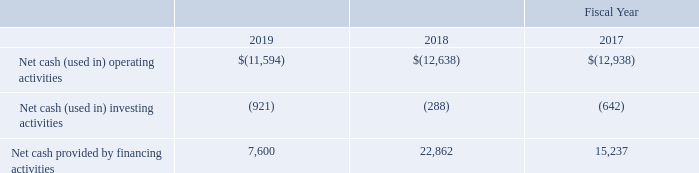Cash balances held at our foreign subsidiaries were approximately $548,000 and $656,000 at December 29, 2019 and December 30, 2018, respectively. Earnings from our foreign subsidiaries are currently deemed to be indefinitely reinvested. We do not expect such reinvestment to affect our liquidity and capital resources, and we continually evaluate our liquidity needs and ability to meet global cash requirements as a part of our overall capital deployment strategy. Factors which affect our liquidity, capital resources and global capital deployment strategy include anticipated cash flows, the ability to repatriate cash in a tax efficient manner, funding requirements for operations and investment activities, acquisitions and divestitures and capital market conditions.
In summary, our cash flows were as follows (in thousands):
Net Cash from Operating Activities
In 2019, net cash used in operating activities was $11.6 million, which was primarily due to a net loss of $15.4 million, adjusted for non-cash charges of $4.3 million. Non-cash charges consisted primarily stock-based compensation expense of $3.1 million and depreciation and amortization of long-lived assets and certain definite- lived intangible assets of $1.2 million. In addition, changes in working capital accounts used cash of $392,000 as a result of a decrease in accounts payable and accrued liabilities of $1.5 million, partially offset by cash inflow from a decrease in inventory of $483,000, a decrease in accounts receivable of $218,000, a decrease in other assets of $229,000 and an increase in deferred revenue of $158,000.
In 2018, net cash used in operating activities was $12.6 million, and resulted primarily from a net loss of $13.8 million, adjusted for non-cash charges of $3.6 million. These non-cash charges included write-downs of inventories in the amount of $386,000 to reflect excess quantities, depreciation and amortization of our long-lived assets of $1.3 million and stock-based compensation of $1.9 million. In addition, changes in working capital accounts used cash of $2.4 million as a result of an increase in accounts receivable of $1.3 million, an increase in gross inventory of $662,000, and an increase in other assets of $879,000, partially offset by an increase in accrued liabilities of $235,000 and an increase in trade payables of $223,000.
In 2017, net cash used in operating activities was $12.9 million, and resulted primarily from a net loss of $14.1 million, adjusted for non-cash charges of $3.1 million. These non-cash charges included write-downs of inventories in the amount of $232,000 to reflect excess quantities, depreciation and amortization of our long-lived assets of $1.4 million and stock-based compensation of $1.4 million. In addition, changes in working capital accounts used cash of $1.9 million as a result of an increase in accounts receivable of $86,000, an increase in gross inventory of $1.8 million, and a decrease of accounts payable of $145,000, partially offset by an increase in accrued liabilities of $72,000.
Net Cash from Investing Activities
Net cash used for investing activities in 2019 was $921,000, which was primarily attributable to the leasehold improvements and computer equipment at the new office premises of $576,000 and capitalization of internal use software of $365,000.
Net cash used for investing activities in 2018 was $288,000, primarily for capital expenditures to acquire manufacturing equipment and software, which was partially offset by proceeds from the sale of old equipment.
Net cash used for investing activities in 2017 was $642,000, primarily for capital expenditures to acquire manufacturing equipment and software.
Net Cash from Financing Activities
In 2019, net cash provided by financing activities was $7.6 million, primarily attributable to the net proceeds from the issuance of 1.3 million shares of common stock in June 2019. These inflows were partially offset by scheduled repayments of finance lease obligations and tax payments related to net settlement of stock awards.
In 2018, net cash provided by financing activities was $22.9 million, resulting from the additional borrowing of $9.0 million under the line of credit, net cash proceeds of $13.9 million from our common stock offering in May 2018 and proceeds of $676,000 from the issuance of common shares to employees under our equity plans. These proceeds were partially offset by scheduled payments of finance lease obligations and tax payments related to net settlement of stock awards.
In 2017, net cash provided by financing activities was $15.2 million, resulting from the proceeds of $15.2 million from our stock offering in March 2017 and proceeds of $352,000 from the issuance of common shares to employees under our equity plans, net of taxes paid related to net settlement of equity awards of $198,000. These proceeds were partially offset by payments of $344,000 under the terms of our capital software lease obligations.
We require substantial cash to fund our business. However, we believe that our existing cash and cash equivalents, together with available financial resources from the Revolving Facility will be sufficient to satisfy our operations and capital expenditures over the next twelve months. OurRevolving Facility will expire in September 2021, and we expect to renew this line of credit or find an alternative lender prior to the expiration date. Further, any violations of debt covenants may restrict our access to any additional cash draws from the revolving line of credit, and may require our immediate repayment of the outstanding debt amounts. After the next twelve months, our cash requirements will depend on many factors, including our level of revenue and gross profit, the market acceptance of our existing and new products, the levels at which we maintain inventories and accounts receivable, costs of securing access to adequate manufacturing capacity, new product development efforts, capital expenditures and the level of our operating expenses. In order to satisfy our longer term liquidity requirements, we may be required to raise additional equity or debt financing. There can be no assurance that financing will be available at commercially acceptable terms or at all.
What are the respective net cash used in operating activities in 2017 and 2018?
Answer scale should be: thousand. 12,938, 12,638. What are the respective net cash used in operating activities in 2018 and 2019?
Answer scale should be: thousand. 12,638, 11,594. What are the respective net cash used in investing activities in 2017 and 2018?
Answer scale should be: thousand. 642, 288. What is the total net cash used in operating activities in 2017 and 2018?
Answer scale should be: thousand. (12,938 + 12,638)
Answer: 25576. What is the average net cash used in operating activities in 2017 and 2018?
Answer scale should be: thousand. (12,938 + 12,638)/2 
Answer: 12788. What is the value of the net cash used in investing activities in 2017 as a percentage of the net cash used in investing activities in 2019?
Answer scale should be: percent. 642/921 
Answer: 69.71. 